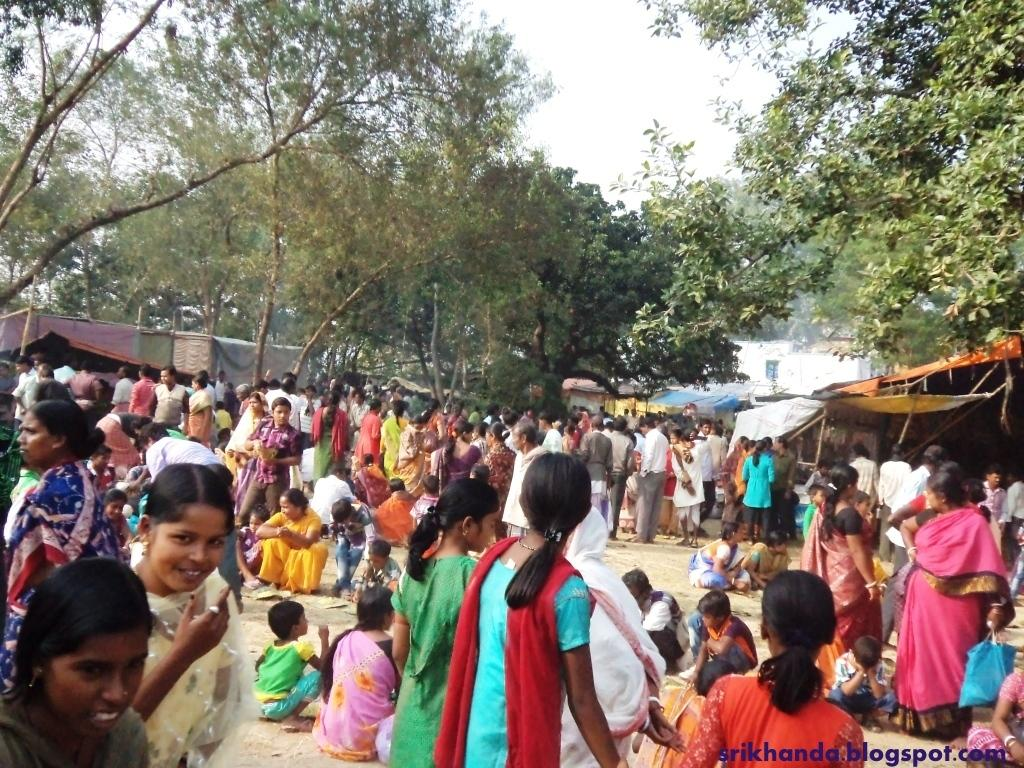What are the people in the image doing? There is a group of people standing on the ground, and some people are sitting. What can be seen in the background of the image? There are sheds, at least one building, a group of trees, and the sky visible in the background. How many giants can be seen in the image? There are no giants present in the image. What type of trip are the people taking in the image? There is no indication of a trip in the image; it simply shows a group of people standing and sitting. 